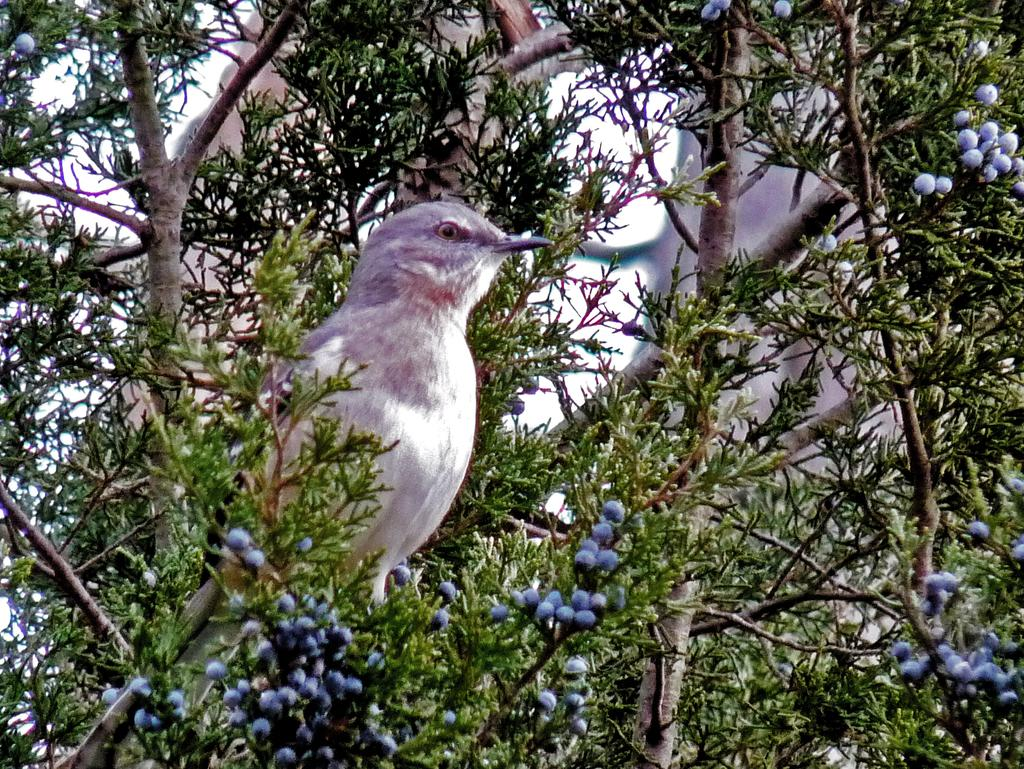What type of animal is in the image? There is a bird in the image. Where is the bird located? The bird is on a tree branch. What can be seen in the background of the image? There are trees and the sky visible in the background of the image. What route does the bird take to reach the apparatus in the image? There is no apparatus present in the image, and therefore no route can be determined. 